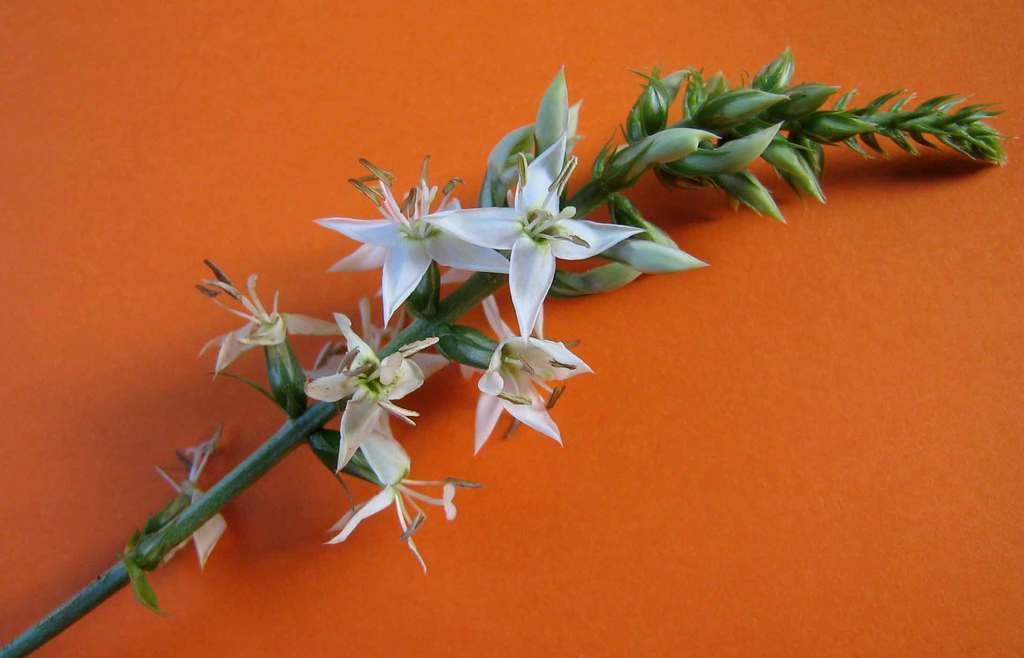Please provide a concise description of this image. In this image there are flowers. The background is orange in color. 